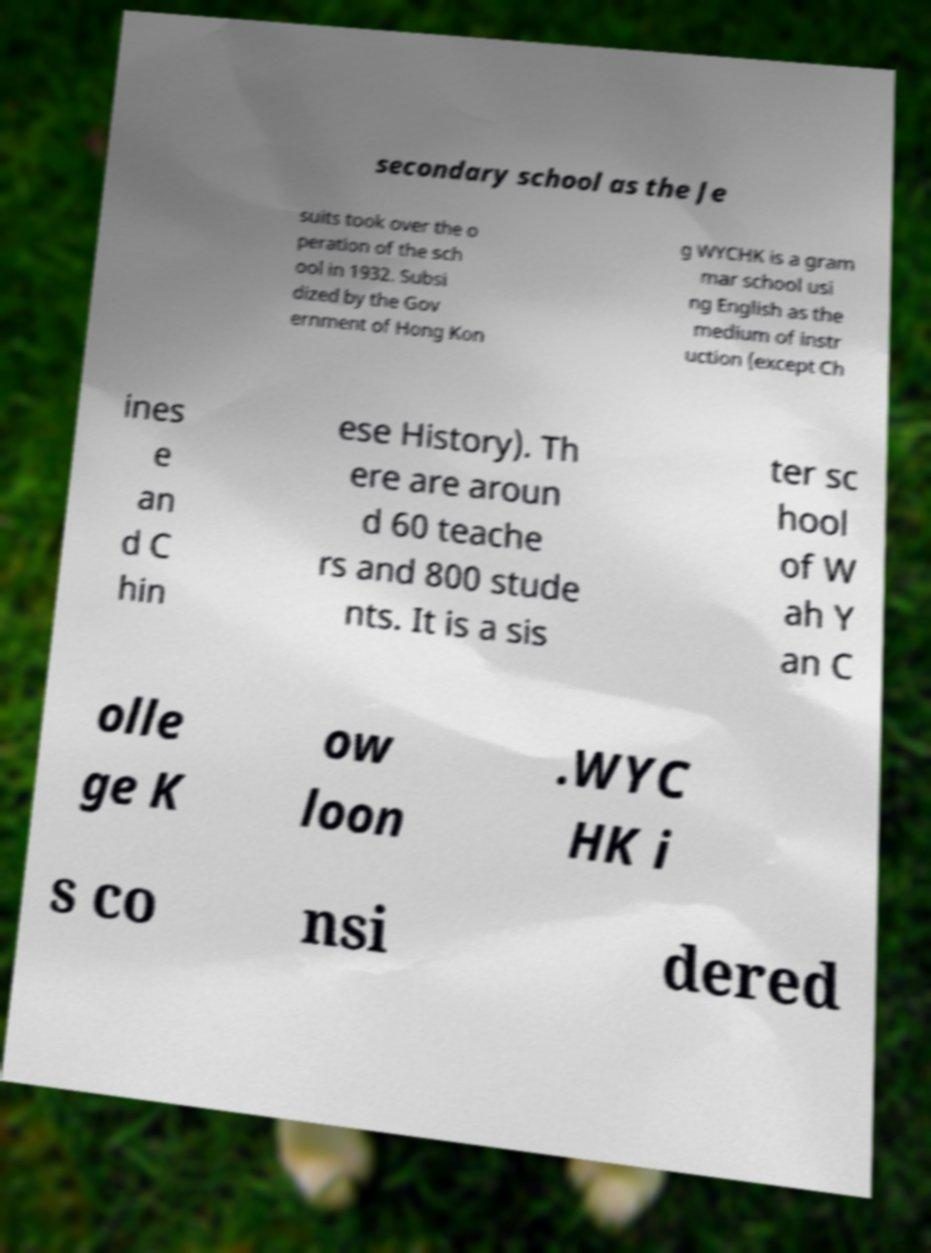Can you accurately transcribe the text from the provided image for me? secondary school as the Je suits took over the o peration of the sch ool in 1932. Subsi dized by the Gov ernment of Hong Kon g WYCHK is a gram mar school usi ng English as the medium of instr uction (except Ch ines e an d C hin ese History). Th ere are aroun d 60 teache rs and 800 stude nts. It is a sis ter sc hool of W ah Y an C olle ge K ow loon .WYC HK i s co nsi dered 